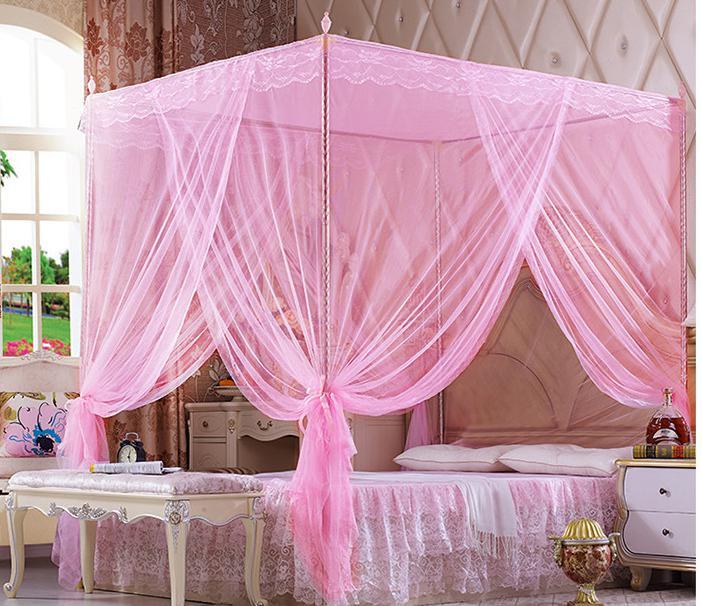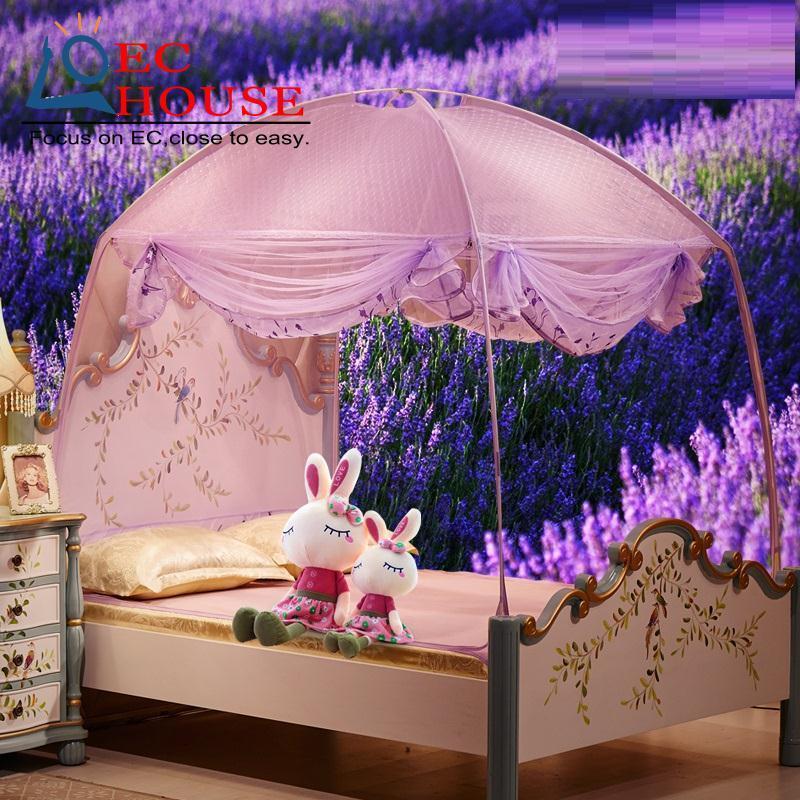The first image is the image on the left, the second image is the image on the right. Analyze the images presented: Is the assertion "A brunette woman in a negligee is posed with one of the purple canopy beds." valid? Answer yes or no. No. The first image is the image on the left, the second image is the image on the right. Considering the images on both sides, is "One of the images includes a human." valid? Answer yes or no. No. 